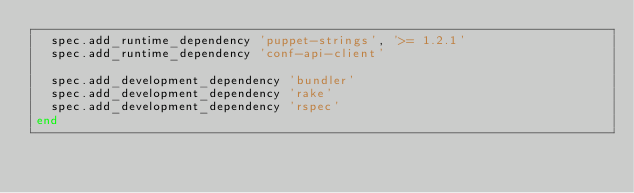<code> <loc_0><loc_0><loc_500><loc_500><_Ruby_>  spec.add_runtime_dependency 'puppet-strings', '>= 1.2.1'
  spec.add_runtime_dependency 'conf-api-client'

  spec.add_development_dependency 'bundler'
  spec.add_development_dependency 'rake'
  spec.add_development_dependency 'rspec'
end
</code> 